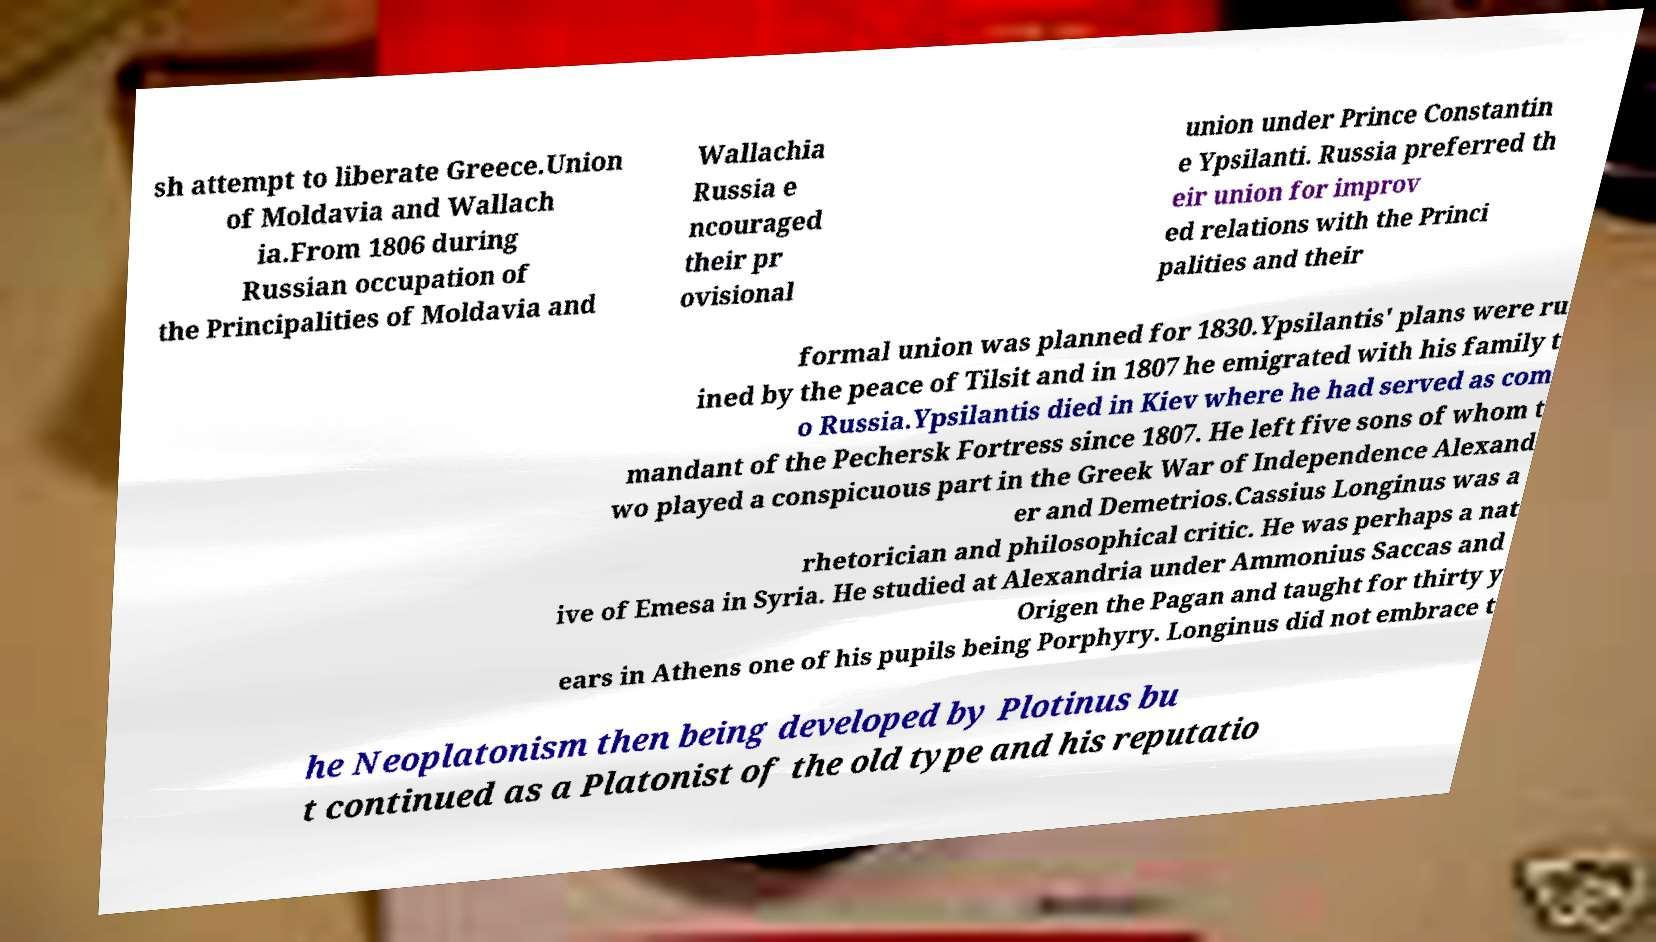Could you assist in decoding the text presented in this image and type it out clearly? sh attempt to liberate Greece.Union of Moldavia and Wallach ia.From 1806 during Russian occupation of the Principalities of Moldavia and Wallachia Russia e ncouraged their pr ovisional union under Prince Constantin e Ypsilanti. Russia preferred th eir union for improv ed relations with the Princi palities and their formal union was planned for 1830.Ypsilantis' plans were ru ined by the peace of Tilsit and in 1807 he emigrated with his family t o Russia.Ypsilantis died in Kiev where he had served as com mandant of the Pechersk Fortress since 1807. He left five sons of whom t wo played a conspicuous part in the Greek War of Independence Alexand er and Demetrios.Cassius Longinus was a rhetorician and philosophical critic. He was perhaps a nat ive of Emesa in Syria. He studied at Alexandria under Ammonius Saccas and Origen the Pagan and taught for thirty y ears in Athens one of his pupils being Porphyry. Longinus did not embrace t he Neoplatonism then being developed by Plotinus bu t continued as a Platonist of the old type and his reputatio 